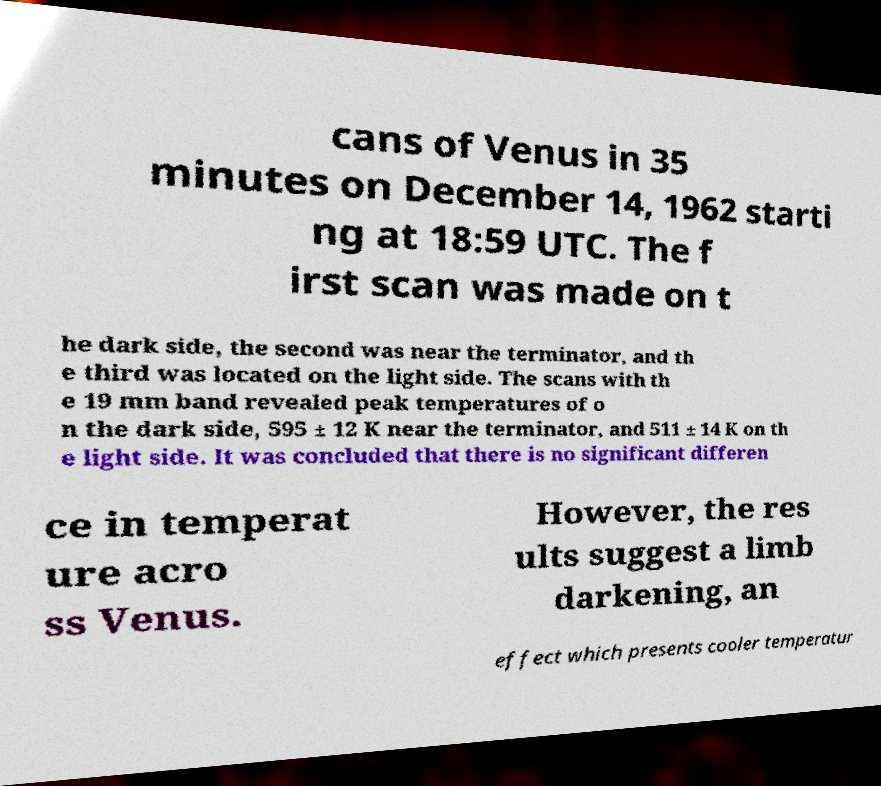I need the written content from this picture converted into text. Can you do that? cans of Venus in 35 minutes on December 14, 1962 starti ng at 18:59 UTC. The f irst scan was made on t he dark side, the second was near the terminator, and th e third was located on the light side. The scans with th e 19 mm band revealed peak temperatures of o n the dark side, 595 ± 12 K near the terminator, and 511 ± 14 K on th e light side. It was concluded that there is no significant differen ce in temperat ure acro ss Venus. However, the res ults suggest a limb darkening, an effect which presents cooler temperatur 